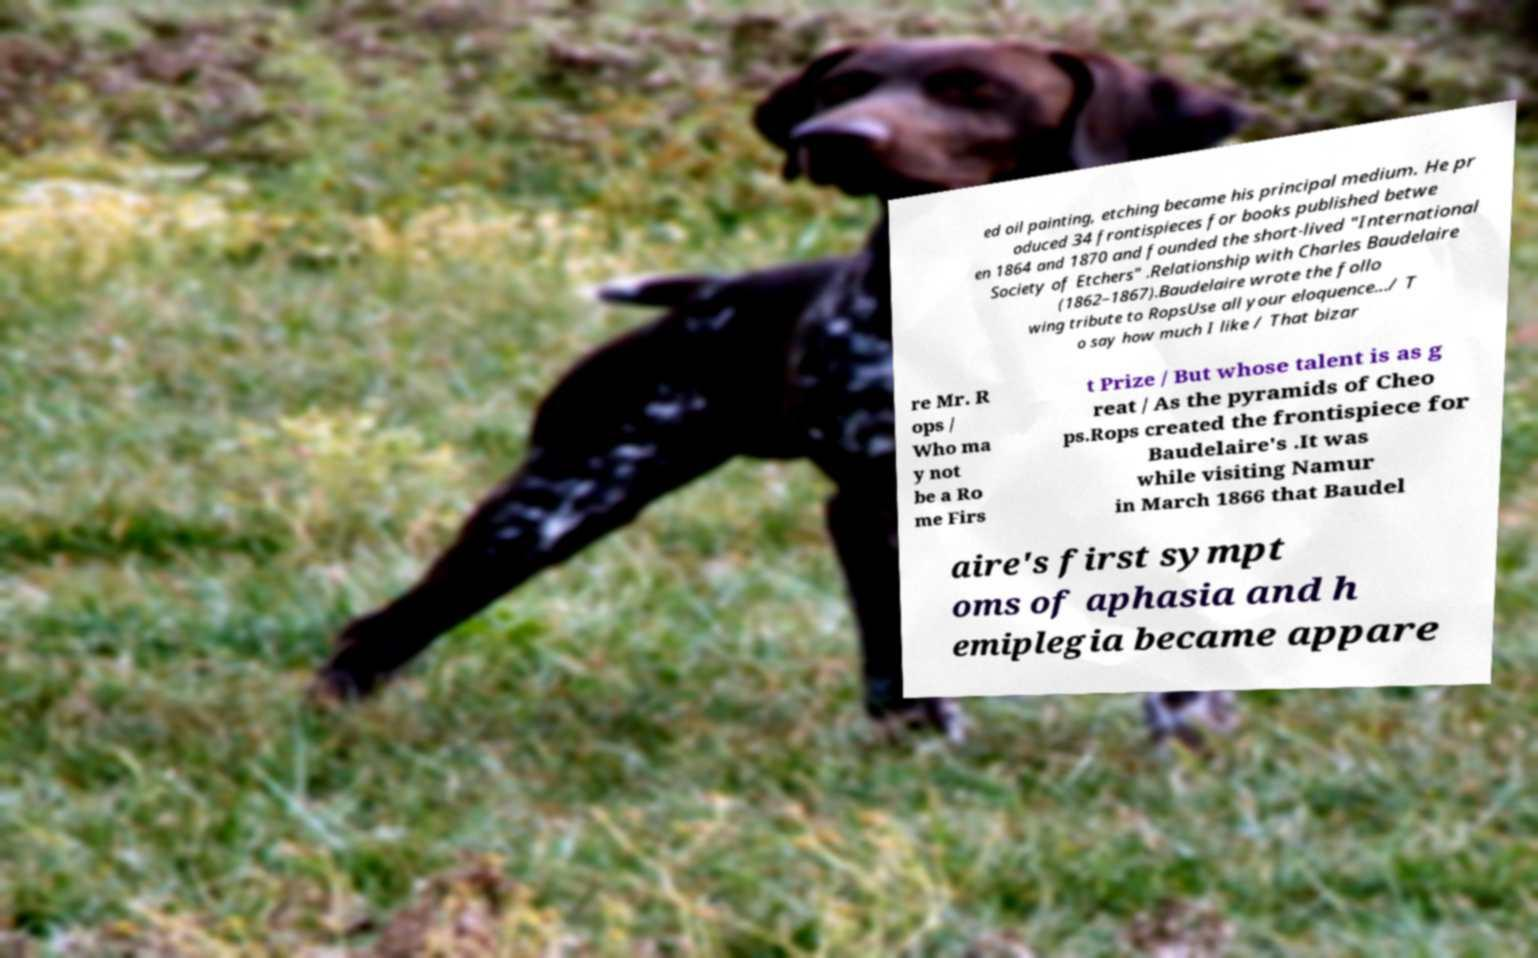There's text embedded in this image that I need extracted. Can you transcribe it verbatim? ed oil painting, etching became his principal medium. He pr oduced 34 frontispieces for books published betwe en 1864 and 1870 and founded the short-lived "International Society of Etchers" .Relationship with Charles Baudelaire (1862–1867).Baudelaire wrote the follo wing tribute to RopsUse all your eloquence.../ T o say how much I like / That bizar re Mr. R ops / Who ma y not be a Ro me Firs t Prize / But whose talent is as g reat / As the pyramids of Cheo ps.Rops created the frontispiece for Baudelaire's .It was while visiting Namur in March 1866 that Baudel aire's first sympt oms of aphasia and h emiplegia became appare 